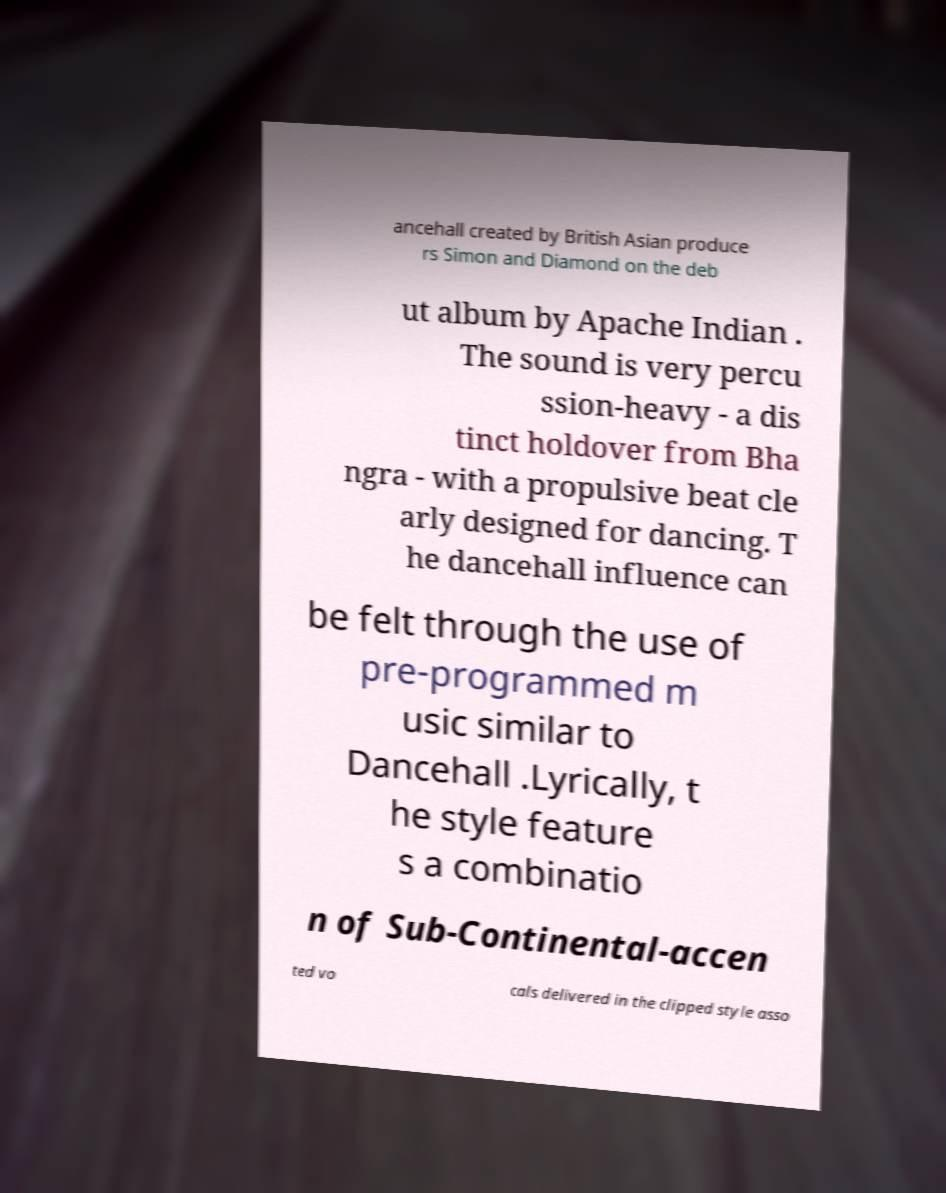What messages or text are displayed in this image? I need them in a readable, typed format. ancehall created by British Asian produce rs Simon and Diamond on the deb ut album by Apache Indian . The sound is very percu ssion-heavy - a dis tinct holdover from Bha ngra - with a propulsive beat cle arly designed for dancing. T he dancehall influence can be felt through the use of pre-programmed m usic similar to Dancehall .Lyrically, t he style feature s a combinatio n of Sub-Continental-accen ted vo cals delivered in the clipped style asso 